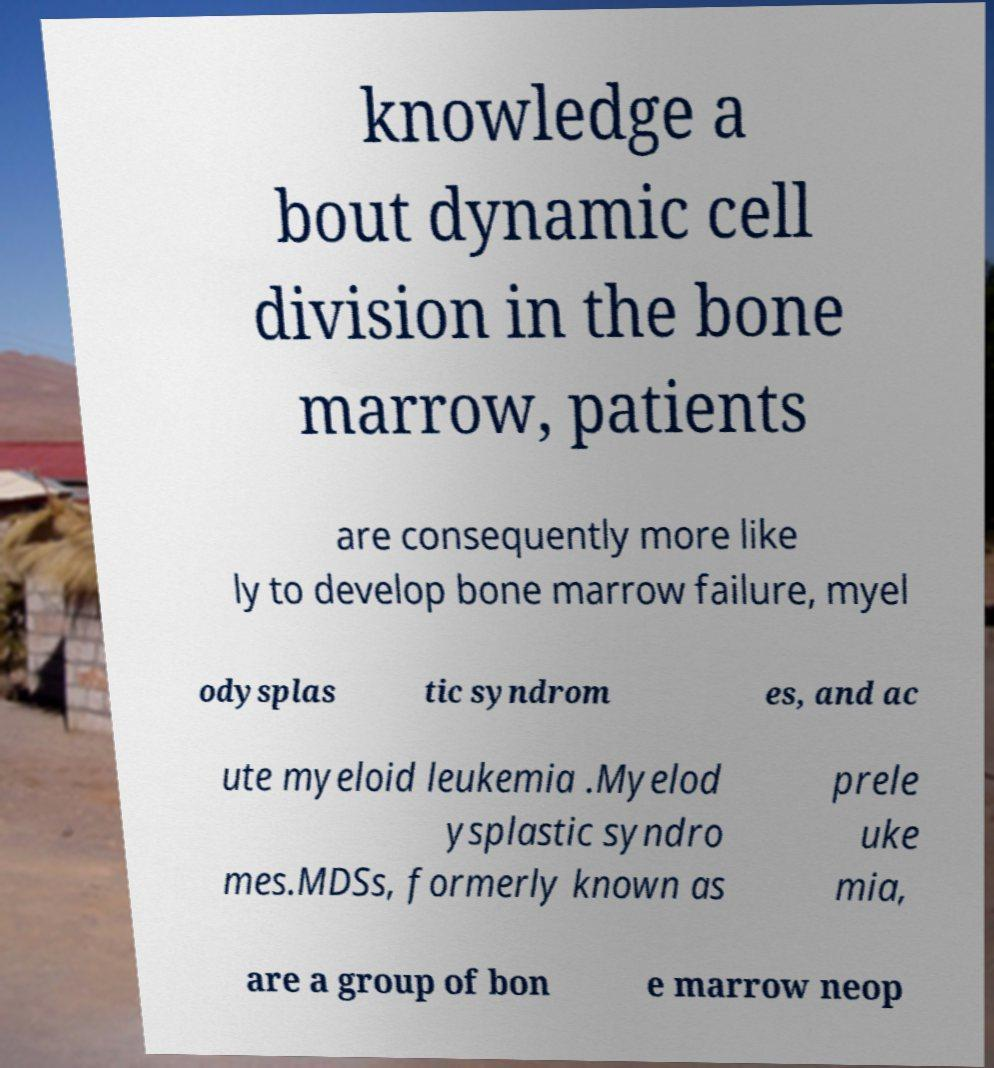There's text embedded in this image that I need extracted. Can you transcribe it verbatim? knowledge a bout dynamic cell division in the bone marrow, patients are consequently more like ly to develop bone marrow failure, myel odysplas tic syndrom es, and ac ute myeloid leukemia .Myelod ysplastic syndro mes.MDSs, formerly known as prele uke mia, are a group of bon e marrow neop 